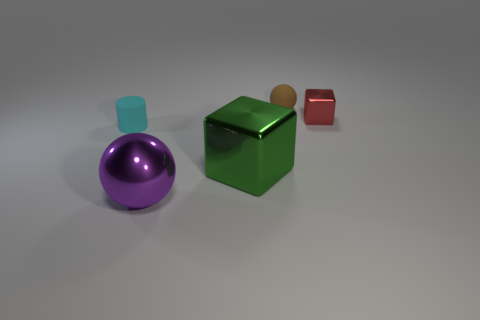Add 1 big brown rubber cylinders. How many objects exist? 6 Subtract all blocks. How many objects are left? 3 Subtract all big green shiny things. Subtract all purple metallic objects. How many objects are left? 3 Add 4 tiny rubber things. How many tiny rubber things are left? 6 Add 5 big cyan spheres. How many big cyan spheres exist? 5 Subtract 0 cyan balls. How many objects are left? 5 